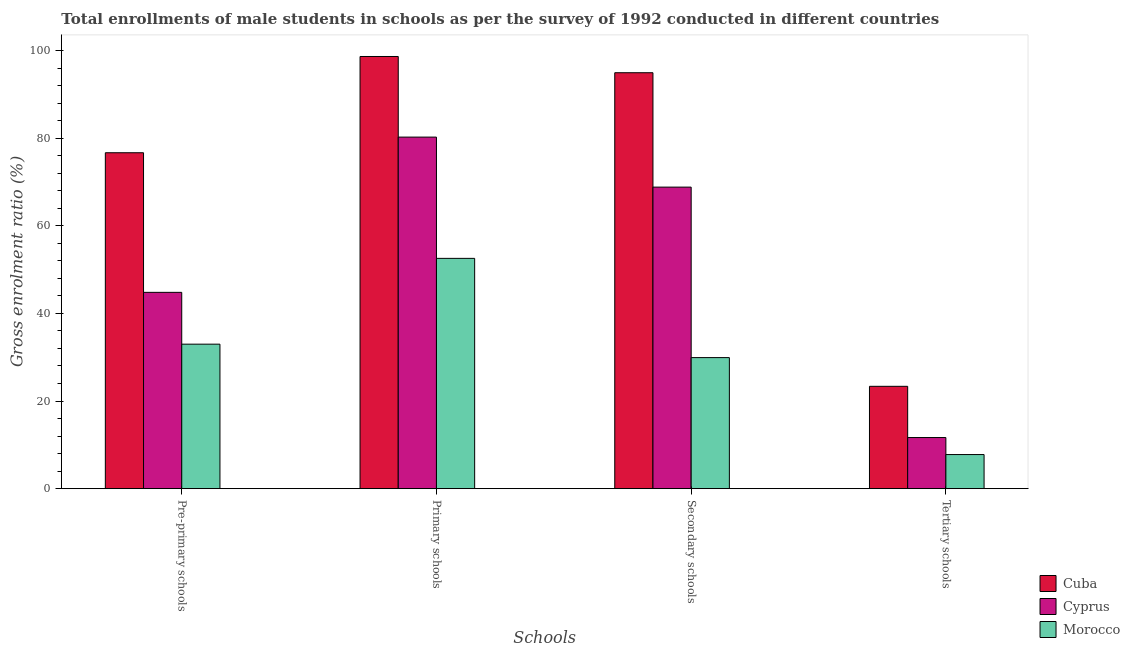How many different coloured bars are there?
Your answer should be very brief. 3. How many groups of bars are there?
Make the answer very short. 4. Are the number of bars per tick equal to the number of legend labels?
Your answer should be very brief. Yes. Are the number of bars on each tick of the X-axis equal?
Your answer should be very brief. Yes. How many bars are there on the 2nd tick from the left?
Your answer should be compact. 3. What is the label of the 3rd group of bars from the left?
Offer a very short reply. Secondary schools. What is the gross enrolment ratio(male) in tertiary schools in Cyprus?
Provide a short and direct response. 11.67. Across all countries, what is the maximum gross enrolment ratio(male) in primary schools?
Offer a terse response. 98.63. Across all countries, what is the minimum gross enrolment ratio(male) in tertiary schools?
Give a very brief answer. 7.79. In which country was the gross enrolment ratio(male) in pre-primary schools maximum?
Offer a terse response. Cuba. In which country was the gross enrolment ratio(male) in tertiary schools minimum?
Offer a terse response. Morocco. What is the total gross enrolment ratio(male) in secondary schools in the graph?
Ensure brevity in your answer.  193.66. What is the difference between the gross enrolment ratio(male) in secondary schools in Cyprus and that in Cuba?
Your answer should be compact. -26.11. What is the difference between the gross enrolment ratio(male) in primary schools in Morocco and the gross enrolment ratio(male) in secondary schools in Cyprus?
Offer a very short reply. -16.26. What is the average gross enrolment ratio(male) in pre-primary schools per country?
Your response must be concise. 51.48. What is the difference between the gross enrolment ratio(male) in secondary schools and gross enrolment ratio(male) in tertiary schools in Cuba?
Offer a terse response. 71.57. In how many countries, is the gross enrolment ratio(male) in tertiary schools greater than 16 %?
Your response must be concise. 1. What is the ratio of the gross enrolment ratio(male) in primary schools in Morocco to that in Cuba?
Offer a very short reply. 0.53. Is the gross enrolment ratio(male) in primary schools in Cuba less than that in Cyprus?
Provide a succinct answer. No. What is the difference between the highest and the second highest gross enrolment ratio(male) in pre-primary schools?
Offer a very short reply. 31.86. What is the difference between the highest and the lowest gross enrolment ratio(male) in primary schools?
Offer a very short reply. 46.07. In how many countries, is the gross enrolment ratio(male) in tertiary schools greater than the average gross enrolment ratio(male) in tertiary schools taken over all countries?
Your response must be concise. 1. Is the sum of the gross enrolment ratio(male) in tertiary schools in Cyprus and Cuba greater than the maximum gross enrolment ratio(male) in primary schools across all countries?
Your response must be concise. No. Is it the case that in every country, the sum of the gross enrolment ratio(male) in pre-primary schools and gross enrolment ratio(male) in primary schools is greater than the sum of gross enrolment ratio(male) in tertiary schools and gross enrolment ratio(male) in secondary schools?
Offer a terse response. No. What does the 1st bar from the left in Secondary schools represents?
Your answer should be very brief. Cuba. What does the 2nd bar from the right in Pre-primary schools represents?
Give a very brief answer. Cyprus. How many bars are there?
Make the answer very short. 12. Are all the bars in the graph horizontal?
Provide a succinct answer. No. How many countries are there in the graph?
Make the answer very short. 3. What is the difference between two consecutive major ticks on the Y-axis?
Provide a succinct answer. 20. Are the values on the major ticks of Y-axis written in scientific E-notation?
Ensure brevity in your answer.  No. Does the graph contain grids?
Provide a short and direct response. No. How are the legend labels stacked?
Ensure brevity in your answer.  Vertical. What is the title of the graph?
Make the answer very short. Total enrollments of male students in schools as per the survey of 1992 conducted in different countries. Does "Ireland" appear as one of the legend labels in the graph?
Offer a terse response. No. What is the label or title of the X-axis?
Keep it short and to the point. Schools. What is the label or title of the Y-axis?
Your answer should be very brief. Gross enrolment ratio (%). What is the Gross enrolment ratio (%) in Cuba in Pre-primary schools?
Your answer should be compact. 76.66. What is the Gross enrolment ratio (%) in Cyprus in Pre-primary schools?
Your response must be concise. 44.8. What is the Gross enrolment ratio (%) in Morocco in Pre-primary schools?
Make the answer very short. 32.98. What is the Gross enrolment ratio (%) in Cuba in Primary schools?
Provide a succinct answer. 98.63. What is the Gross enrolment ratio (%) of Cyprus in Primary schools?
Your response must be concise. 80.24. What is the Gross enrolment ratio (%) in Morocco in Primary schools?
Keep it short and to the point. 52.56. What is the Gross enrolment ratio (%) in Cuba in Secondary schools?
Ensure brevity in your answer.  94.93. What is the Gross enrolment ratio (%) of Cyprus in Secondary schools?
Provide a short and direct response. 68.82. What is the Gross enrolment ratio (%) of Morocco in Secondary schools?
Provide a succinct answer. 29.91. What is the Gross enrolment ratio (%) of Cuba in Tertiary schools?
Your answer should be very brief. 23.36. What is the Gross enrolment ratio (%) in Cyprus in Tertiary schools?
Your response must be concise. 11.67. What is the Gross enrolment ratio (%) of Morocco in Tertiary schools?
Keep it short and to the point. 7.79. Across all Schools, what is the maximum Gross enrolment ratio (%) in Cuba?
Offer a terse response. 98.63. Across all Schools, what is the maximum Gross enrolment ratio (%) of Cyprus?
Offer a very short reply. 80.24. Across all Schools, what is the maximum Gross enrolment ratio (%) of Morocco?
Your response must be concise. 52.56. Across all Schools, what is the minimum Gross enrolment ratio (%) of Cuba?
Your answer should be compact. 23.36. Across all Schools, what is the minimum Gross enrolment ratio (%) of Cyprus?
Provide a short and direct response. 11.67. Across all Schools, what is the minimum Gross enrolment ratio (%) of Morocco?
Ensure brevity in your answer.  7.79. What is the total Gross enrolment ratio (%) of Cuba in the graph?
Offer a very short reply. 293.58. What is the total Gross enrolment ratio (%) in Cyprus in the graph?
Give a very brief answer. 205.53. What is the total Gross enrolment ratio (%) in Morocco in the graph?
Your answer should be very brief. 123.24. What is the difference between the Gross enrolment ratio (%) of Cuba in Pre-primary schools and that in Primary schools?
Keep it short and to the point. -21.97. What is the difference between the Gross enrolment ratio (%) in Cyprus in Pre-primary schools and that in Primary schools?
Provide a short and direct response. -35.43. What is the difference between the Gross enrolment ratio (%) of Morocco in Pre-primary schools and that in Primary schools?
Make the answer very short. -19.58. What is the difference between the Gross enrolment ratio (%) of Cuba in Pre-primary schools and that in Secondary schools?
Keep it short and to the point. -18.26. What is the difference between the Gross enrolment ratio (%) in Cyprus in Pre-primary schools and that in Secondary schools?
Keep it short and to the point. -24.02. What is the difference between the Gross enrolment ratio (%) in Morocco in Pre-primary schools and that in Secondary schools?
Make the answer very short. 3.07. What is the difference between the Gross enrolment ratio (%) in Cuba in Pre-primary schools and that in Tertiary schools?
Your answer should be compact. 53.31. What is the difference between the Gross enrolment ratio (%) in Cyprus in Pre-primary schools and that in Tertiary schools?
Offer a terse response. 33.14. What is the difference between the Gross enrolment ratio (%) of Morocco in Pre-primary schools and that in Tertiary schools?
Provide a succinct answer. 25.19. What is the difference between the Gross enrolment ratio (%) of Cuba in Primary schools and that in Secondary schools?
Offer a terse response. 3.71. What is the difference between the Gross enrolment ratio (%) of Cyprus in Primary schools and that in Secondary schools?
Make the answer very short. 11.41. What is the difference between the Gross enrolment ratio (%) of Morocco in Primary schools and that in Secondary schools?
Provide a short and direct response. 22.64. What is the difference between the Gross enrolment ratio (%) in Cuba in Primary schools and that in Tertiary schools?
Make the answer very short. 75.28. What is the difference between the Gross enrolment ratio (%) in Cyprus in Primary schools and that in Tertiary schools?
Give a very brief answer. 68.57. What is the difference between the Gross enrolment ratio (%) in Morocco in Primary schools and that in Tertiary schools?
Ensure brevity in your answer.  44.77. What is the difference between the Gross enrolment ratio (%) of Cuba in Secondary schools and that in Tertiary schools?
Give a very brief answer. 71.57. What is the difference between the Gross enrolment ratio (%) of Cyprus in Secondary schools and that in Tertiary schools?
Make the answer very short. 57.15. What is the difference between the Gross enrolment ratio (%) of Morocco in Secondary schools and that in Tertiary schools?
Keep it short and to the point. 22.13. What is the difference between the Gross enrolment ratio (%) in Cuba in Pre-primary schools and the Gross enrolment ratio (%) in Cyprus in Primary schools?
Your response must be concise. -3.57. What is the difference between the Gross enrolment ratio (%) in Cuba in Pre-primary schools and the Gross enrolment ratio (%) in Morocco in Primary schools?
Offer a terse response. 24.1. What is the difference between the Gross enrolment ratio (%) of Cyprus in Pre-primary schools and the Gross enrolment ratio (%) of Morocco in Primary schools?
Offer a very short reply. -7.75. What is the difference between the Gross enrolment ratio (%) of Cuba in Pre-primary schools and the Gross enrolment ratio (%) of Cyprus in Secondary schools?
Offer a terse response. 7.84. What is the difference between the Gross enrolment ratio (%) in Cuba in Pre-primary schools and the Gross enrolment ratio (%) in Morocco in Secondary schools?
Keep it short and to the point. 46.75. What is the difference between the Gross enrolment ratio (%) of Cyprus in Pre-primary schools and the Gross enrolment ratio (%) of Morocco in Secondary schools?
Ensure brevity in your answer.  14.89. What is the difference between the Gross enrolment ratio (%) of Cuba in Pre-primary schools and the Gross enrolment ratio (%) of Cyprus in Tertiary schools?
Your answer should be compact. 65. What is the difference between the Gross enrolment ratio (%) of Cuba in Pre-primary schools and the Gross enrolment ratio (%) of Morocco in Tertiary schools?
Ensure brevity in your answer.  68.88. What is the difference between the Gross enrolment ratio (%) of Cyprus in Pre-primary schools and the Gross enrolment ratio (%) of Morocco in Tertiary schools?
Offer a very short reply. 37.02. What is the difference between the Gross enrolment ratio (%) of Cuba in Primary schools and the Gross enrolment ratio (%) of Cyprus in Secondary schools?
Give a very brief answer. 29.81. What is the difference between the Gross enrolment ratio (%) in Cuba in Primary schools and the Gross enrolment ratio (%) in Morocco in Secondary schools?
Your response must be concise. 68.72. What is the difference between the Gross enrolment ratio (%) of Cyprus in Primary schools and the Gross enrolment ratio (%) of Morocco in Secondary schools?
Offer a terse response. 50.32. What is the difference between the Gross enrolment ratio (%) in Cuba in Primary schools and the Gross enrolment ratio (%) in Cyprus in Tertiary schools?
Provide a short and direct response. 86.96. What is the difference between the Gross enrolment ratio (%) of Cuba in Primary schools and the Gross enrolment ratio (%) of Morocco in Tertiary schools?
Provide a succinct answer. 90.85. What is the difference between the Gross enrolment ratio (%) of Cyprus in Primary schools and the Gross enrolment ratio (%) of Morocco in Tertiary schools?
Make the answer very short. 72.45. What is the difference between the Gross enrolment ratio (%) of Cuba in Secondary schools and the Gross enrolment ratio (%) of Cyprus in Tertiary schools?
Give a very brief answer. 83.26. What is the difference between the Gross enrolment ratio (%) of Cuba in Secondary schools and the Gross enrolment ratio (%) of Morocco in Tertiary schools?
Ensure brevity in your answer.  87.14. What is the difference between the Gross enrolment ratio (%) in Cyprus in Secondary schools and the Gross enrolment ratio (%) in Morocco in Tertiary schools?
Offer a terse response. 61.03. What is the average Gross enrolment ratio (%) of Cuba per Schools?
Your answer should be compact. 73.4. What is the average Gross enrolment ratio (%) in Cyprus per Schools?
Your answer should be compact. 51.38. What is the average Gross enrolment ratio (%) of Morocco per Schools?
Provide a succinct answer. 30.81. What is the difference between the Gross enrolment ratio (%) of Cuba and Gross enrolment ratio (%) of Cyprus in Pre-primary schools?
Provide a short and direct response. 31.86. What is the difference between the Gross enrolment ratio (%) in Cuba and Gross enrolment ratio (%) in Morocco in Pre-primary schools?
Your response must be concise. 43.68. What is the difference between the Gross enrolment ratio (%) in Cyprus and Gross enrolment ratio (%) in Morocco in Pre-primary schools?
Offer a very short reply. 11.82. What is the difference between the Gross enrolment ratio (%) of Cuba and Gross enrolment ratio (%) of Cyprus in Primary schools?
Offer a terse response. 18.4. What is the difference between the Gross enrolment ratio (%) in Cuba and Gross enrolment ratio (%) in Morocco in Primary schools?
Offer a terse response. 46.07. What is the difference between the Gross enrolment ratio (%) in Cyprus and Gross enrolment ratio (%) in Morocco in Primary schools?
Keep it short and to the point. 27.68. What is the difference between the Gross enrolment ratio (%) of Cuba and Gross enrolment ratio (%) of Cyprus in Secondary schools?
Provide a short and direct response. 26.11. What is the difference between the Gross enrolment ratio (%) of Cuba and Gross enrolment ratio (%) of Morocco in Secondary schools?
Your answer should be compact. 65.01. What is the difference between the Gross enrolment ratio (%) of Cyprus and Gross enrolment ratio (%) of Morocco in Secondary schools?
Your response must be concise. 38.91. What is the difference between the Gross enrolment ratio (%) of Cuba and Gross enrolment ratio (%) of Cyprus in Tertiary schools?
Offer a terse response. 11.69. What is the difference between the Gross enrolment ratio (%) of Cuba and Gross enrolment ratio (%) of Morocco in Tertiary schools?
Ensure brevity in your answer.  15.57. What is the difference between the Gross enrolment ratio (%) of Cyprus and Gross enrolment ratio (%) of Morocco in Tertiary schools?
Keep it short and to the point. 3.88. What is the ratio of the Gross enrolment ratio (%) in Cuba in Pre-primary schools to that in Primary schools?
Give a very brief answer. 0.78. What is the ratio of the Gross enrolment ratio (%) in Cyprus in Pre-primary schools to that in Primary schools?
Provide a short and direct response. 0.56. What is the ratio of the Gross enrolment ratio (%) of Morocco in Pre-primary schools to that in Primary schools?
Your response must be concise. 0.63. What is the ratio of the Gross enrolment ratio (%) in Cuba in Pre-primary schools to that in Secondary schools?
Your answer should be compact. 0.81. What is the ratio of the Gross enrolment ratio (%) in Cyprus in Pre-primary schools to that in Secondary schools?
Make the answer very short. 0.65. What is the ratio of the Gross enrolment ratio (%) in Morocco in Pre-primary schools to that in Secondary schools?
Offer a very short reply. 1.1. What is the ratio of the Gross enrolment ratio (%) of Cuba in Pre-primary schools to that in Tertiary schools?
Ensure brevity in your answer.  3.28. What is the ratio of the Gross enrolment ratio (%) of Cyprus in Pre-primary schools to that in Tertiary schools?
Provide a short and direct response. 3.84. What is the ratio of the Gross enrolment ratio (%) in Morocco in Pre-primary schools to that in Tertiary schools?
Make the answer very short. 4.24. What is the ratio of the Gross enrolment ratio (%) in Cuba in Primary schools to that in Secondary schools?
Provide a succinct answer. 1.04. What is the ratio of the Gross enrolment ratio (%) of Cyprus in Primary schools to that in Secondary schools?
Provide a short and direct response. 1.17. What is the ratio of the Gross enrolment ratio (%) in Morocco in Primary schools to that in Secondary schools?
Make the answer very short. 1.76. What is the ratio of the Gross enrolment ratio (%) in Cuba in Primary schools to that in Tertiary schools?
Give a very brief answer. 4.22. What is the ratio of the Gross enrolment ratio (%) in Cyprus in Primary schools to that in Tertiary schools?
Your answer should be very brief. 6.88. What is the ratio of the Gross enrolment ratio (%) in Morocco in Primary schools to that in Tertiary schools?
Provide a succinct answer. 6.75. What is the ratio of the Gross enrolment ratio (%) of Cuba in Secondary schools to that in Tertiary schools?
Make the answer very short. 4.06. What is the ratio of the Gross enrolment ratio (%) in Cyprus in Secondary schools to that in Tertiary schools?
Make the answer very short. 5.9. What is the ratio of the Gross enrolment ratio (%) in Morocco in Secondary schools to that in Tertiary schools?
Give a very brief answer. 3.84. What is the difference between the highest and the second highest Gross enrolment ratio (%) of Cuba?
Keep it short and to the point. 3.71. What is the difference between the highest and the second highest Gross enrolment ratio (%) of Cyprus?
Your response must be concise. 11.41. What is the difference between the highest and the second highest Gross enrolment ratio (%) in Morocco?
Your answer should be very brief. 19.58. What is the difference between the highest and the lowest Gross enrolment ratio (%) in Cuba?
Your answer should be compact. 75.28. What is the difference between the highest and the lowest Gross enrolment ratio (%) in Cyprus?
Your answer should be compact. 68.57. What is the difference between the highest and the lowest Gross enrolment ratio (%) of Morocco?
Your answer should be very brief. 44.77. 